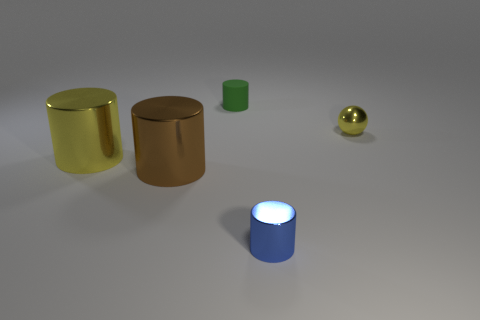Subtract all yellow cylinders. How many cylinders are left? 3 Subtract all yellow cylinders. How many cylinders are left? 3 Subtract all gray cylinders. Subtract all red blocks. How many cylinders are left? 4 Add 2 big purple matte balls. How many objects exist? 7 Subtract all cylinders. How many objects are left? 1 Subtract all purple metal balls. Subtract all yellow metallic cylinders. How many objects are left? 4 Add 5 brown metallic things. How many brown metallic things are left? 6 Add 2 large brown things. How many large brown things exist? 3 Subtract 0 cyan spheres. How many objects are left? 5 